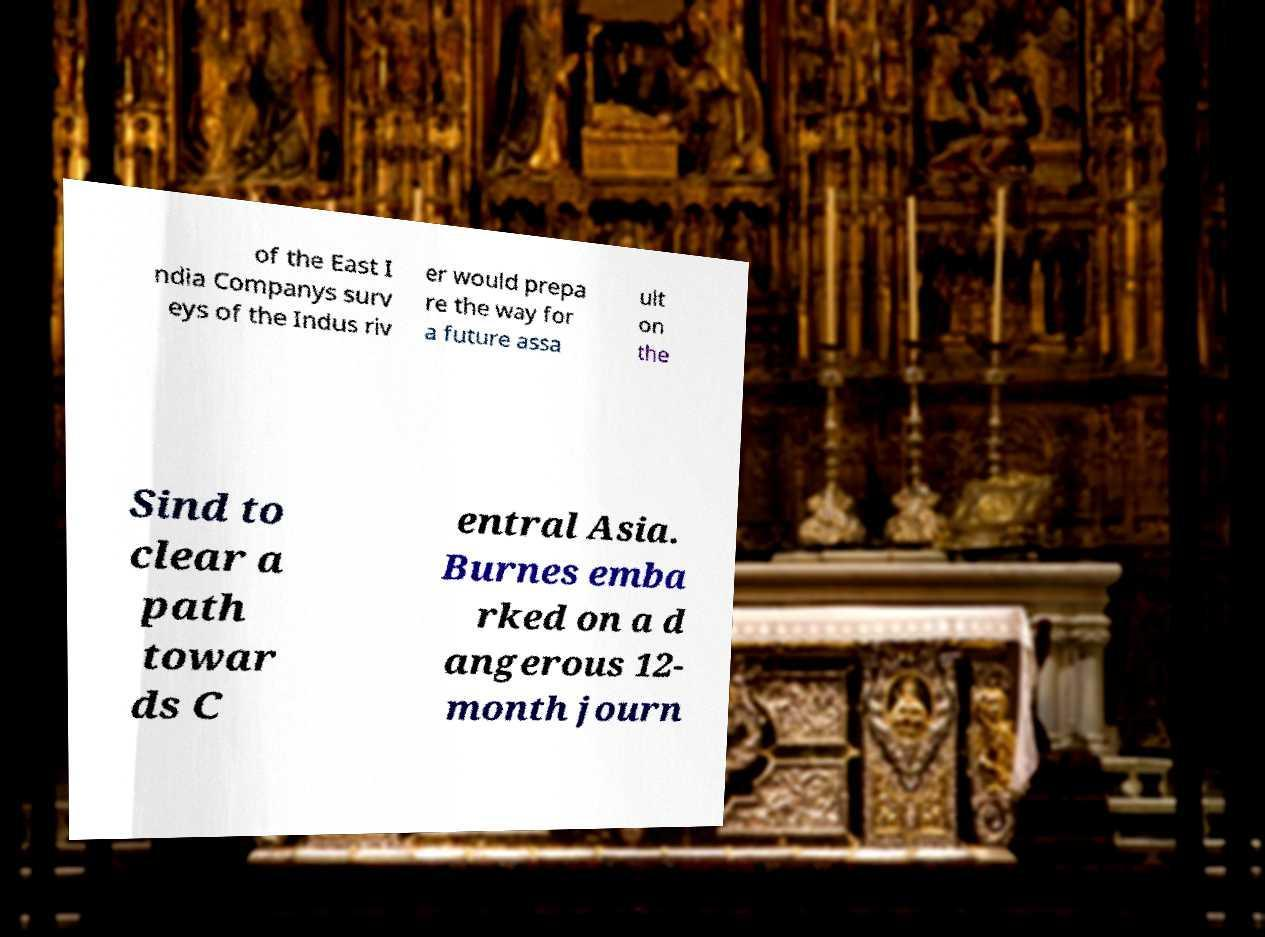Please identify and transcribe the text found in this image. of the East I ndia Companys surv eys of the Indus riv er would prepa re the way for a future assa ult on the Sind to clear a path towar ds C entral Asia. Burnes emba rked on a d angerous 12- month journ 